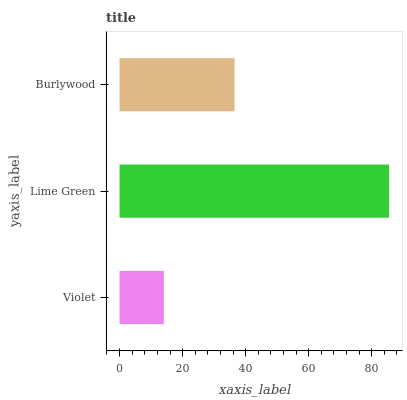Is Violet the minimum?
Answer yes or no. Yes. Is Lime Green the maximum?
Answer yes or no. Yes. Is Burlywood the minimum?
Answer yes or no. No. Is Burlywood the maximum?
Answer yes or no. No. Is Lime Green greater than Burlywood?
Answer yes or no. Yes. Is Burlywood less than Lime Green?
Answer yes or no. Yes. Is Burlywood greater than Lime Green?
Answer yes or no. No. Is Lime Green less than Burlywood?
Answer yes or no. No. Is Burlywood the high median?
Answer yes or no. Yes. Is Burlywood the low median?
Answer yes or no. Yes. Is Violet the high median?
Answer yes or no. No. Is Lime Green the low median?
Answer yes or no. No. 